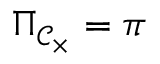Convert formula to latex. <formula><loc_0><loc_0><loc_500><loc_500>\Pi _ { { \mathcal { C } } _ { \times } } = \pi</formula> 